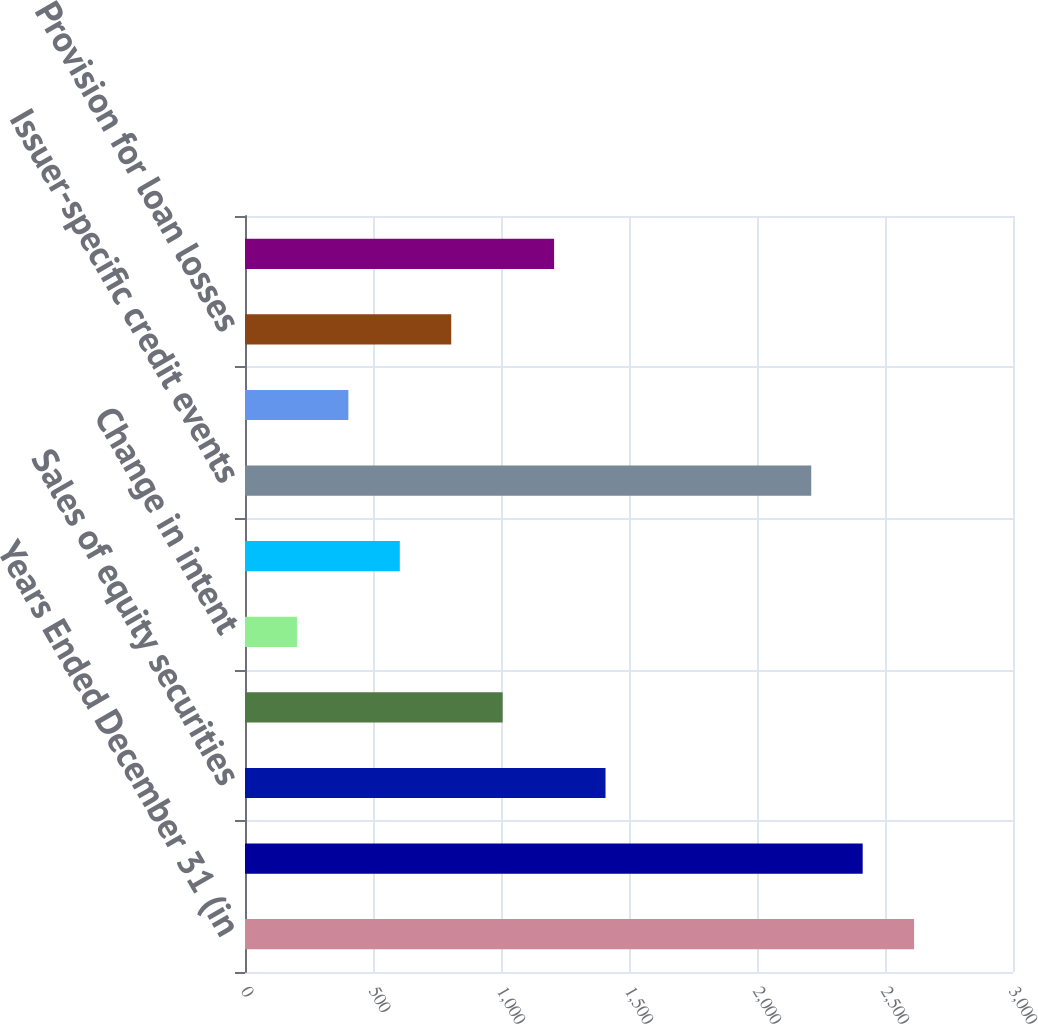Convert chart to OTSL. <chart><loc_0><loc_0><loc_500><loc_500><bar_chart><fcel>Years Ended December 31 (in<fcel>Sales of fixed maturity<fcel>Sales of equity securities<fcel>Severity<fcel>Change in intent<fcel>Foreign currency declines<fcel>Issuer-specific credit events<fcel>Adverse projected cash flows<fcel>Provision for loan losses<fcel>Foreign exchange transactions<nl><fcel>2613.7<fcel>2412.8<fcel>1408.3<fcel>1006.5<fcel>202.9<fcel>604.7<fcel>2211.9<fcel>403.8<fcel>805.6<fcel>1207.4<nl></chart> 